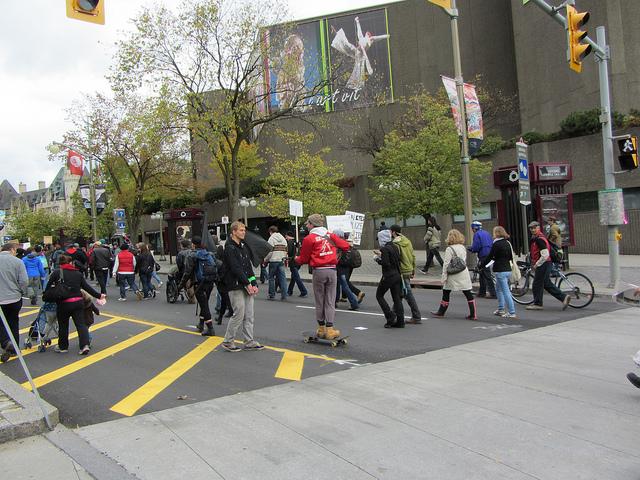Are there palm trees?
Answer briefly. No. Where are the flags?
Write a very short answer. Poles. Are there shadows in the picture?
Concise answer only. Yes. What is sticking out of the plastic bag?
Be succinct. Groceries. What are the people to the right doing?
Keep it brief. Walking. Is the street busy?
Keep it brief. Yes. Does the sign signal to stop or walk?
Keep it brief. Walk. Can cars drive past the man in red?
Short answer required. No. How many people are shown?
Answer briefly. 30. Are there more skateboarders or bikers?
Give a very brief answer. Skateboards. How many people are in the photo?
Write a very short answer. 25. Is there people under the umbrellas?
Give a very brief answer. No. Do you see a train?
Quick response, please. No. Is this photo in black and white?
Keep it brief. No. Is the person in the red shirt jumping?
Write a very short answer. No. What is the ethnicity of the people?
Concise answer only. White. What sports team does the red t shirt depict?
Write a very short answer. Not sure. How many bicycles are shown?
Write a very short answer. 1. What kind of animal?
Concise answer only. None. What are the kids riding?
Answer briefly. Skateboards. Are all the people walking?
Be succinct. Yes. How many bikes?
Write a very short answer. 1. Are the shoes tennis shoes?
Write a very short answer. Yes. Does the lady have shoes on?
Answer briefly. Yes. What is the street made of?
Short answer required. Asphalt. What do the people have on their heads?
Concise answer only. Hats. Is this a recent photo?
Short answer required. Yes. Are the skateboarders tired?
Quick response, please. No. Is this a skate park?
Quick response, please. No. What does the woman pushing the stroller have in her hand?
Answer briefly. Bag. What is the person standing on?
Keep it brief. Skateboard. How many people are sitting?
Concise answer only. 0. Are there any pizza places selling pizza around?
Be succinct. No. Is it night time?
Give a very brief answer. No. What number is on the man's shirt?
Concise answer only. 0. What color is the traffic light?
Short answer required. Red. Is it raining?
Give a very brief answer. No. Are the people together?
Give a very brief answer. Yes. What is the man in the pink shirt riding?
Short answer required. Skateboard. 